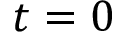<formula> <loc_0><loc_0><loc_500><loc_500>t = 0</formula> 